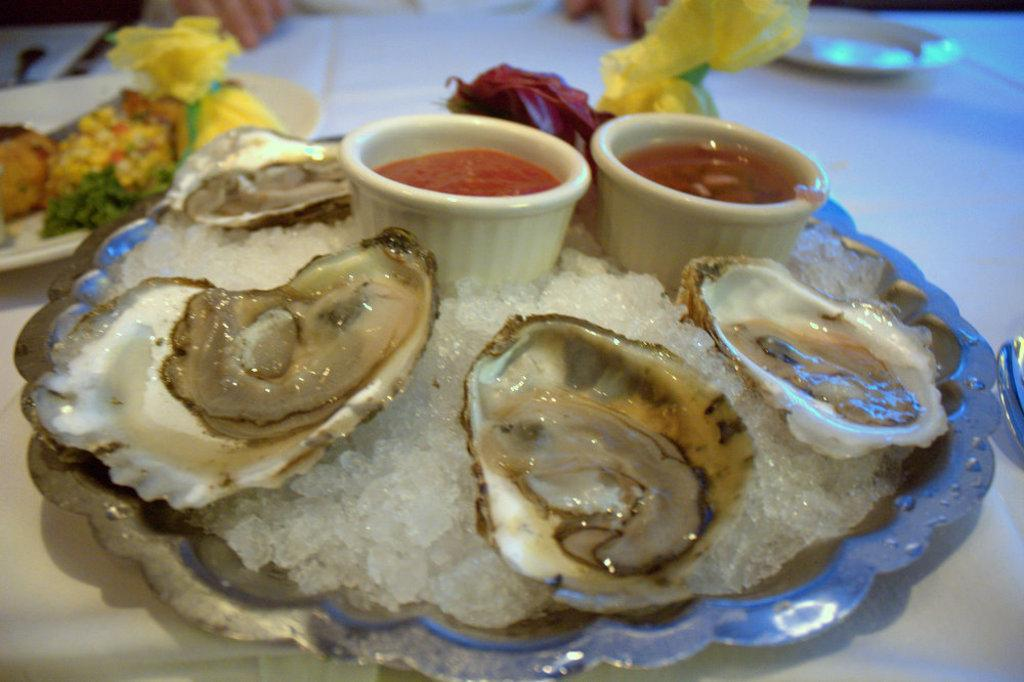What types of dishes are present in the image? There are plates and bowls in the image. What is contained within the dishes? There is food in the image. What can be seen on the table? There are objects on the table. What color is the table? The table is white. Who might be interacting with the food and dishes? Fingers of people are visible at the top of the image, suggesting that they are interacting with the food and dishes. Can you tell me what type of minister is present at the seashore in the image? There is no minister or seashore present in the image; it features a table with dishes and food. What mathematical operation is being performed with the addition of objects in the image? There is no addition or mathematical operation being performed in the image; it simply shows a table with dishes and food. 